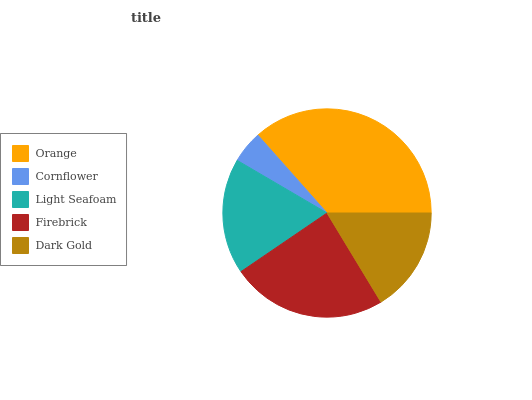Is Cornflower the minimum?
Answer yes or no. Yes. Is Orange the maximum?
Answer yes or no. Yes. Is Light Seafoam the minimum?
Answer yes or no. No. Is Light Seafoam the maximum?
Answer yes or no. No. Is Light Seafoam greater than Cornflower?
Answer yes or no. Yes. Is Cornflower less than Light Seafoam?
Answer yes or no. Yes. Is Cornflower greater than Light Seafoam?
Answer yes or no. No. Is Light Seafoam less than Cornflower?
Answer yes or no. No. Is Light Seafoam the high median?
Answer yes or no. Yes. Is Light Seafoam the low median?
Answer yes or no. Yes. Is Firebrick the high median?
Answer yes or no. No. Is Cornflower the low median?
Answer yes or no. No. 